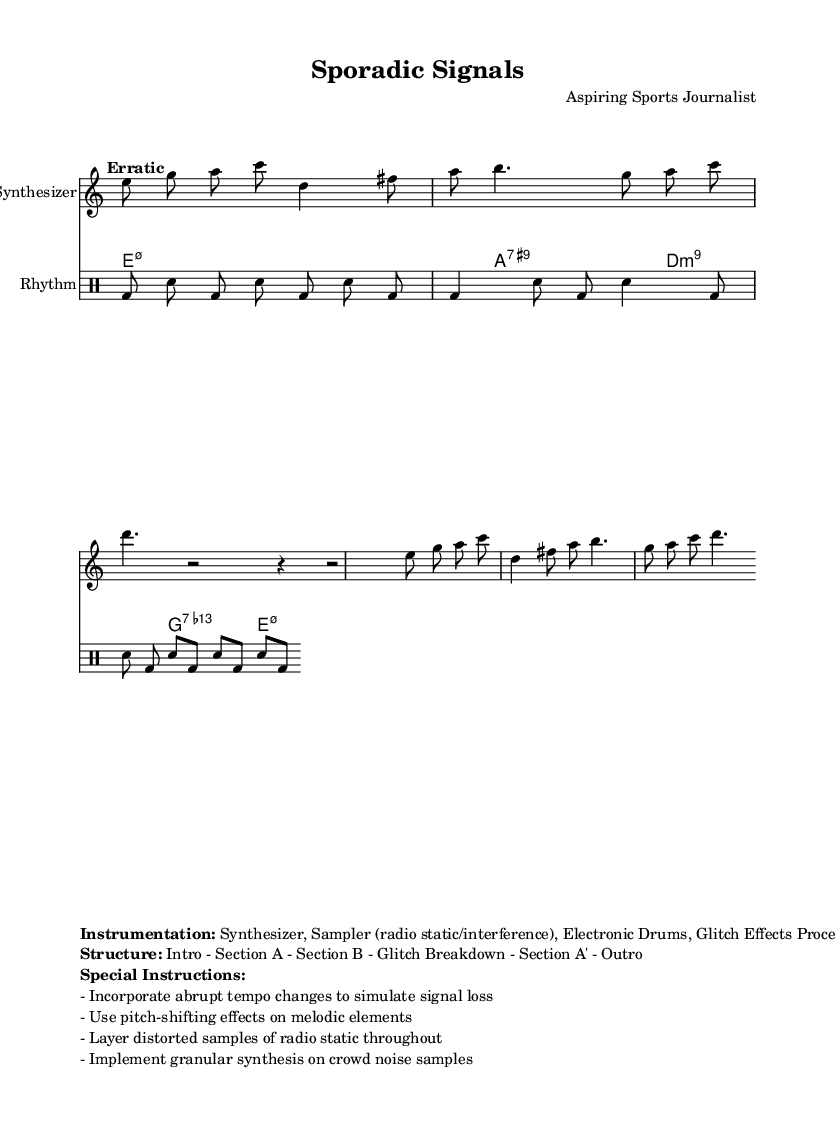What is the time signature of this music? The time signature at the beginning of the score indicates a change to 7/8 time, as seen near the melody section.
Answer: 7/8 What is the tempo marking for this composition? The tempo marking specified at the beginning shows it as "Erratic" with a range of 60-120 beats per minute.
Answer: Erratic 4 = 60-120 What instrument is primarily featured in the melody section? The score indicates that the melody is performed on a synthesizer, as specified in the instrumentation section.
Answer: Synthesizer How many bars are present in Section A of the melody? By counting the measures in the melody section up until the Section B indication, there are two bars before transitioning.
Answer: 2 bars What rhythmic pattern is used in the drum part? The rhythmic pattern consists of alternating bass drum and snare hits, detailed in the rhythmic pattern section of the score.
Answer: Bass drum and snare What special instructions are provided for this piece? The special instructions detail specific performance techniques, such as abrupt tempo changes and pitch-shifting effects.
Answer: Incorporate abrupt tempo changes How does the structure of the composition progress? The structure can be viewed as an organized sequence, starting with an intro, proceeding through sections A and B, and concluding with an outro, as explicitly laid out.
Answer: Intro - Section A - Section B - Glitch Breakdown - Section A' - Outro 